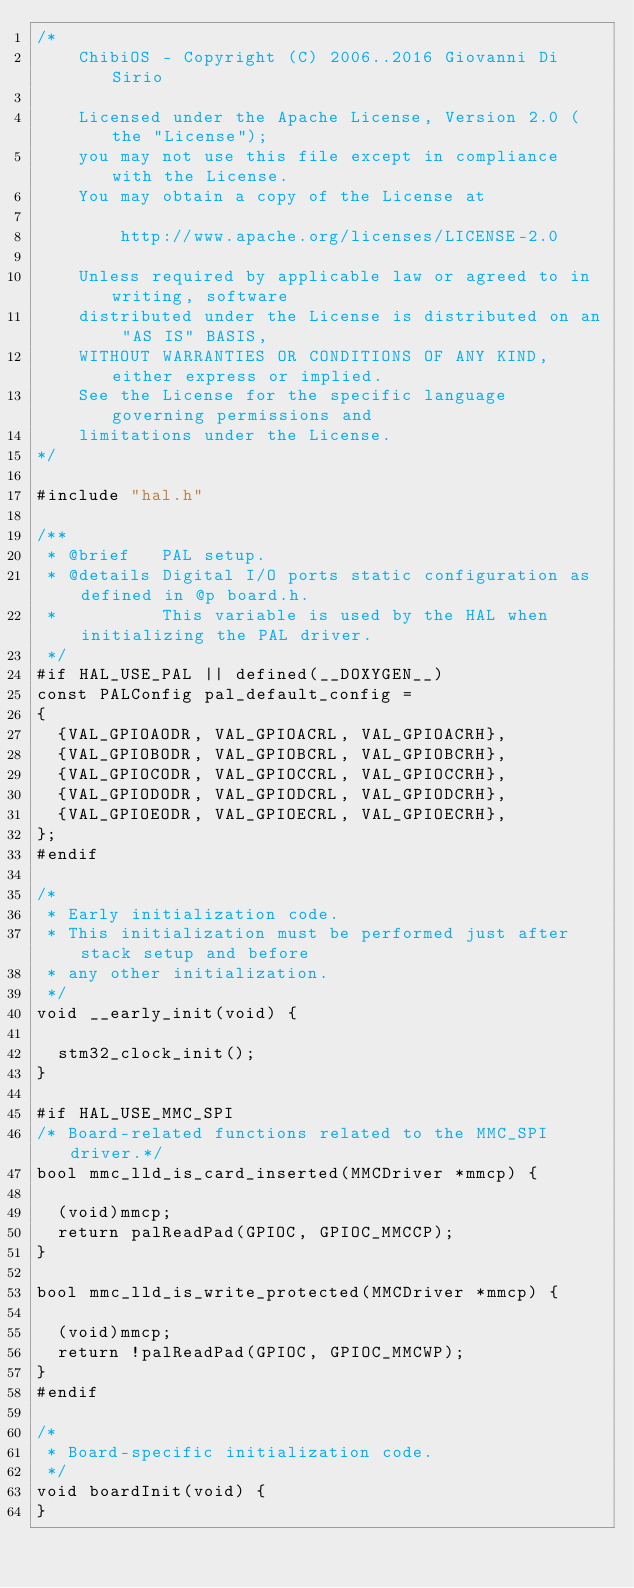Convert code to text. <code><loc_0><loc_0><loc_500><loc_500><_C_>/*
    ChibiOS - Copyright (C) 2006..2016 Giovanni Di Sirio

    Licensed under the Apache License, Version 2.0 (the "License");
    you may not use this file except in compliance with the License.
    You may obtain a copy of the License at

        http://www.apache.org/licenses/LICENSE-2.0

    Unless required by applicable law or agreed to in writing, software
    distributed under the License is distributed on an "AS IS" BASIS,
    WITHOUT WARRANTIES OR CONDITIONS OF ANY KIND, either express or implied.
    See the License for the specific language governing permissions and
    limitations under the License.
*/

#include "hal.h"

/**
 * @brief   PAL setup.
 * @details Digital I/O ports static configuration as defined in @p board.h.
 *          This variable is used by the HAL when initializing the PAL driver.
 */
#if HAL_USE_PAL || defined(__DOXYGEN__)
const PALConfig pal_default_config =
{
  {VAL_GPIOAODR, VAL_GPIOACRL, VAL_GPIOACRH},
  {VAL_GPIOBODR, VAL_GPIOBCRL, VAL_GPIOBCRH},
  {VAL_GPIOCODR, VAL_GPIOCCRL, VAL_GPIOCCRH},
  {VAL_GPIODODR, VAL_GPIODCRL, VAL_GPIODCRH},
  {VAL_GPIOEODR, VAL_GPIOECRL, VAL_GPIOECRH},
};
#endif

/*
 * Early initialization code.
 * This initialization must be performed just after stack setup and before
 * any other initialization.
 */
void __early_init(void) {

  stm32_clock_init();
}

#if HAL_USE_MMC_SPI
/* Board-related functions related to the MMC_SPI driver.*/
bool mmc_lld_is_card_inserted(MMCDriver *mmcp) {

  (void)mmcp;
  return palReadPad(GPIOC, GPIOC_MMCCP);
}

bool mmc_lld_is_write_protected(MMCDriver *mmcp) {

  (void)mmcp;
  return !palReadPad(GPIOC, GPIOC_MMCWP);
}
#endif

/*
 * Board-specific initialization code.
 */
void boardInit(void) {
}
</code> 